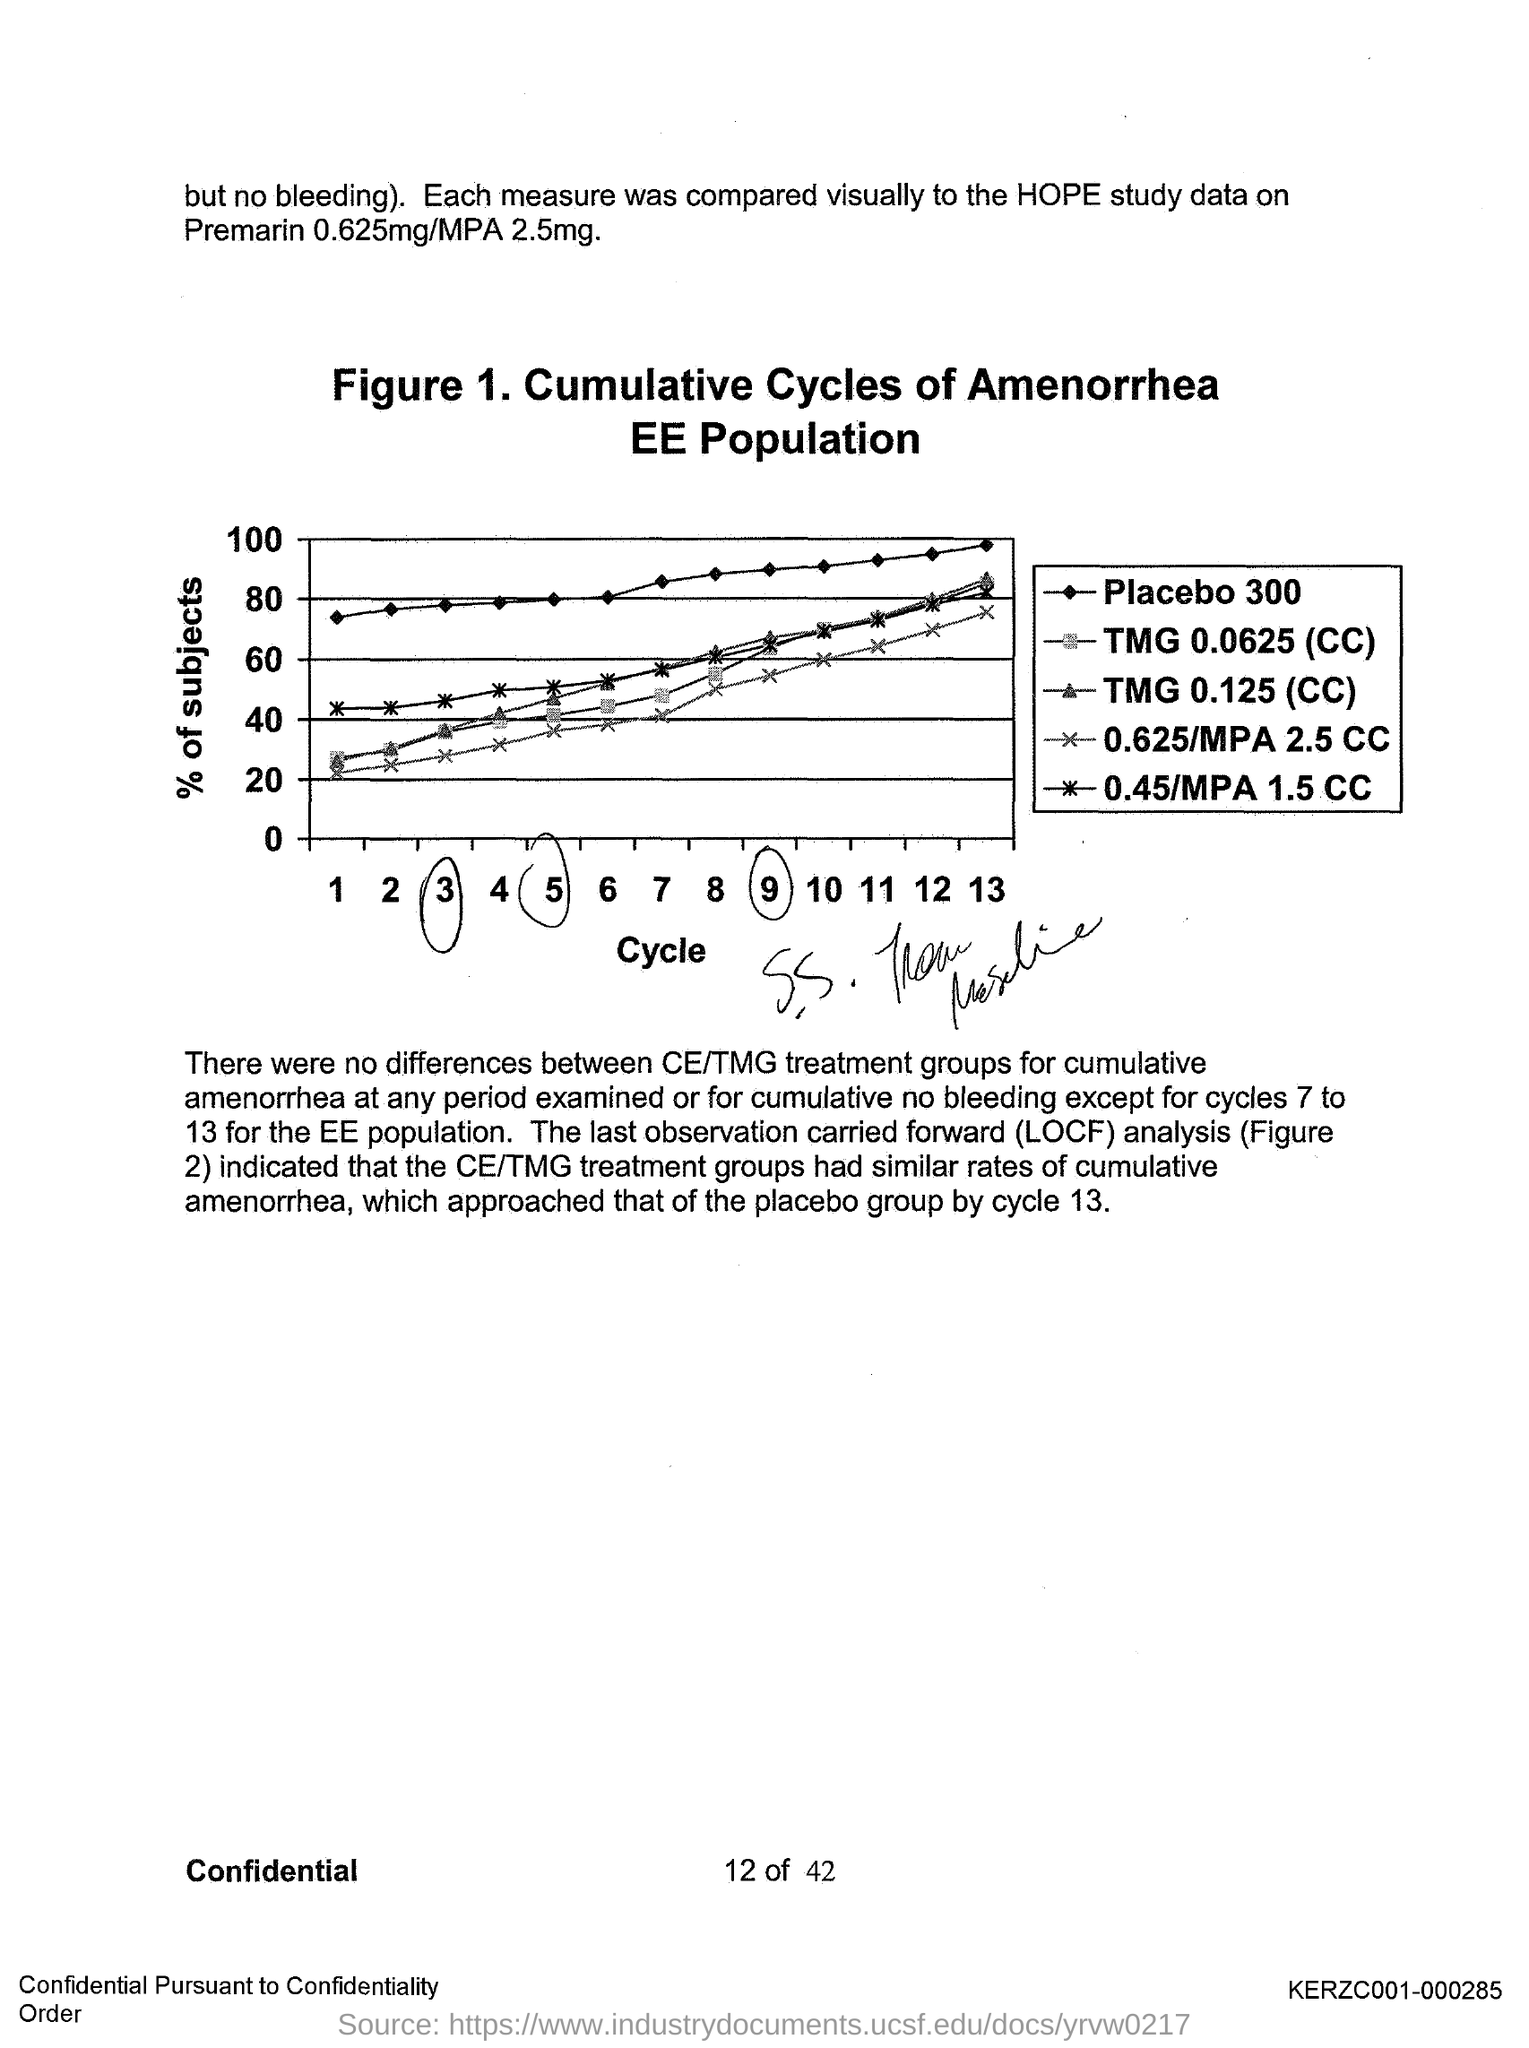What does Figure 1. in this document represent?
Your response must be concise. Cumulative Cycles of Amenorrhea EE Population. What is the fullform of LOCF?
Your answer should be very brief. Last observation carried forward. 